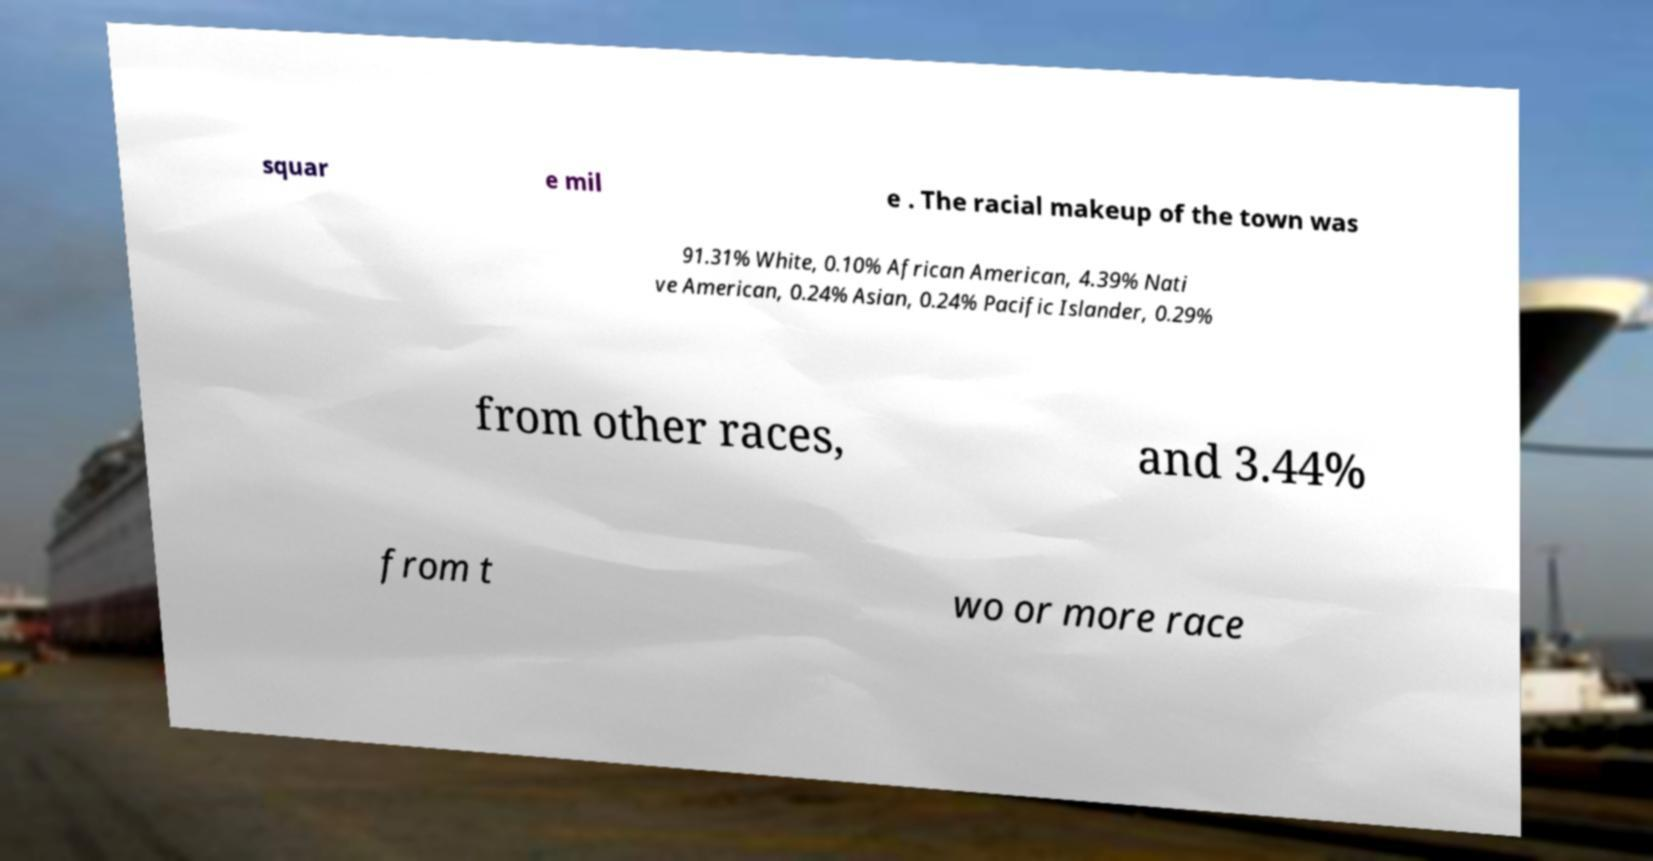Can you read and provide the text displayed in the image?This photo seems to have some interesting text. Can you extract and type it out for me? squar e mil e . The racial makeup of the town was 91.31% White, 0.10% African American, 4.39% Nati ve American, 0.24% Asian, 0.24% Pacific Islander, 0.29% from other races, and 3.44% from t wo or more race 